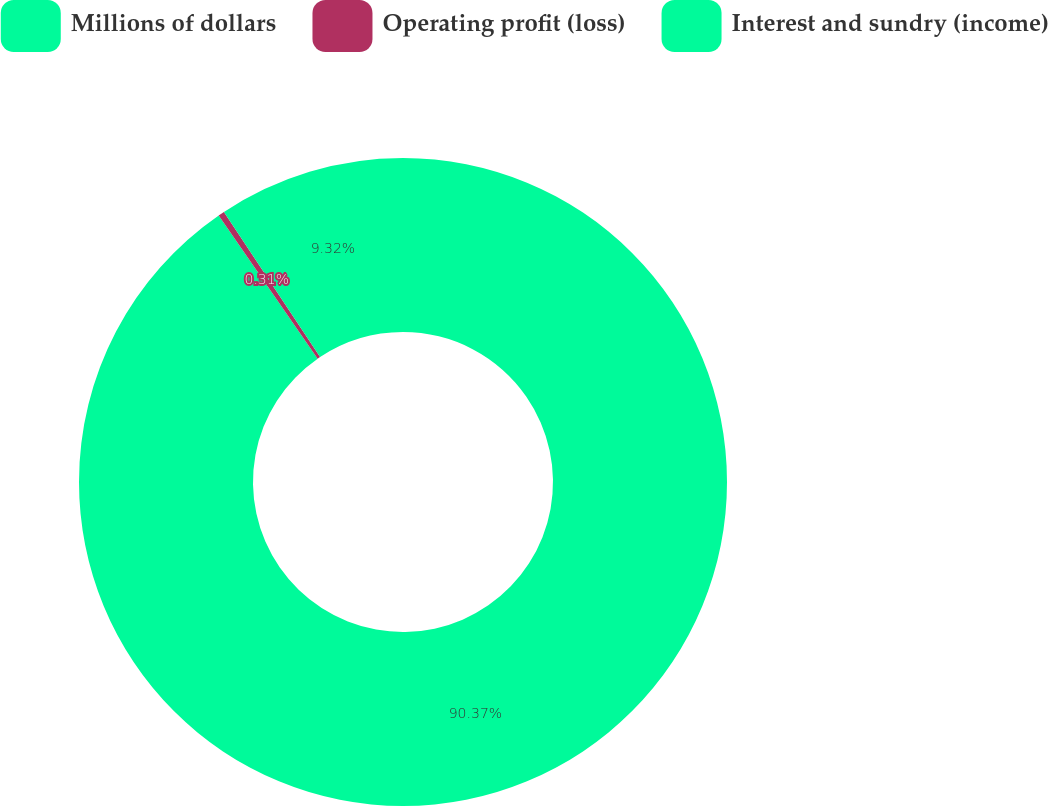Convert chart to OTSL. <chart><loc_0><loc_0><loc_500><loc_500><pie_chart><fcel>Millions of dollars<fcel>Operating profit (loss)<fcel>Interest and sundry (income)<nl><fcel>90.37%<fcel>0.31%<fcel>9.32%<nl></chart> 